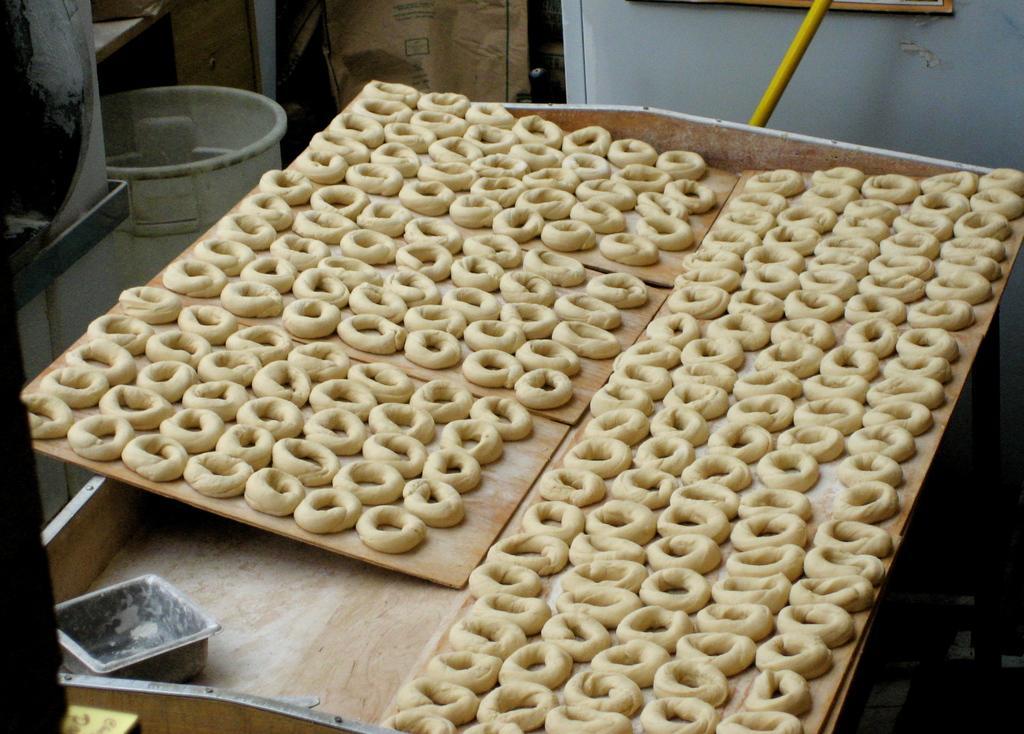Please provide a concise description of this image. In the image we can see food items, kept on the wooden surface. This is a container and other objects. 